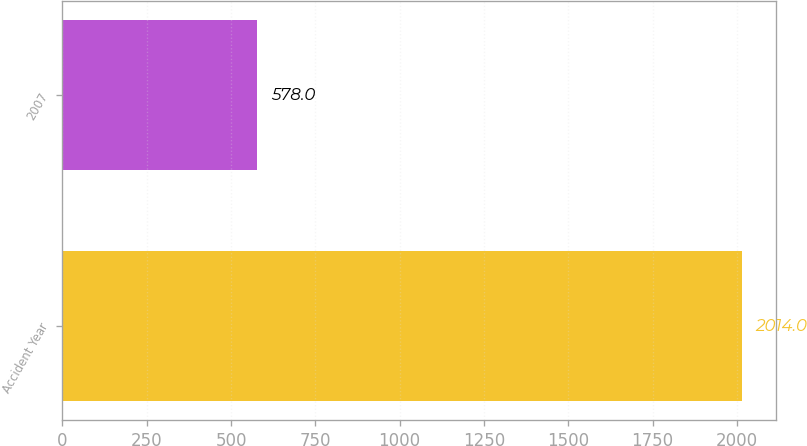Convert chart. <chart><loc_0><loc_0><loc_500><loc_500><bar_chart><fcel>Accident Year<fcel>2007<nl><fcel>2014<fcel>578<nl></chart> 